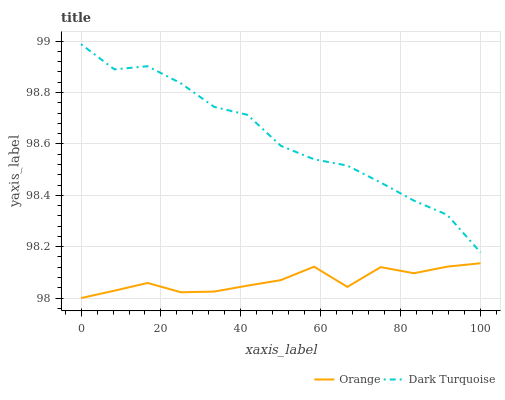Does Dark Turquoise have the minimum area under the curve?
Answer yes or no. No. Is Dark Turquoise the smoothest?
Answer yes or no. No. Does Dark Turquoise have the lowest value?
Answer yes or no. No. Is Orange less than Dark Turquoise?
Answer yes or no. Yes. Is Dark Turquoise greater than Orange?
Answer yes or no. Yes. Does Orange intersect Dark Turquoise?
Answer yes or no. No. 